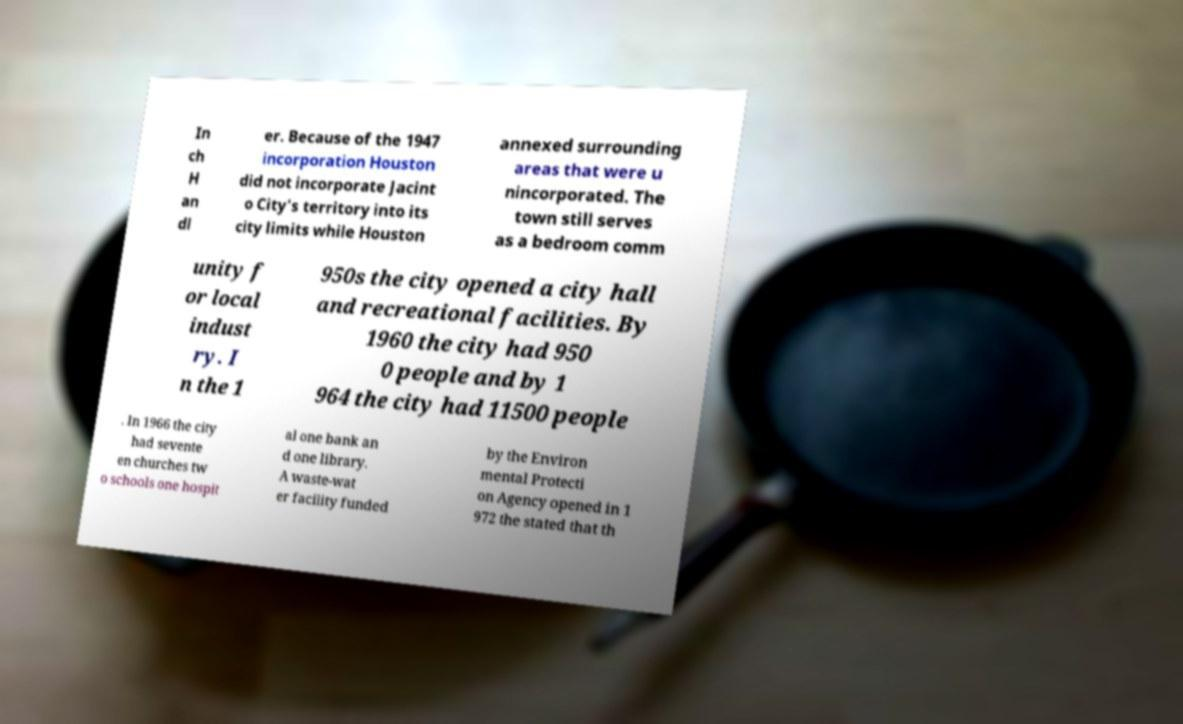Could you extract and type out the text from this image? In ch H an dl er. Because of the 1947 incorporation Houston did not incorporate Jacint o City's territory into its city limits while Houston annexed surrounding areas that were u nincorporated. The town still serves as a bedroom comm unity f or local indust ry. I n the 1 950s the city opened a city hall and recreational facilities. By 1960 the city had 950 0 people and by 1 964 the city had 11500 people . In 1966 the city had sevente en churches tw o schools one hospit al one bank an d one library. A waste-wat er facility funded by the Environ mental Protecti on Agency opened in 1 972 the stated that th 